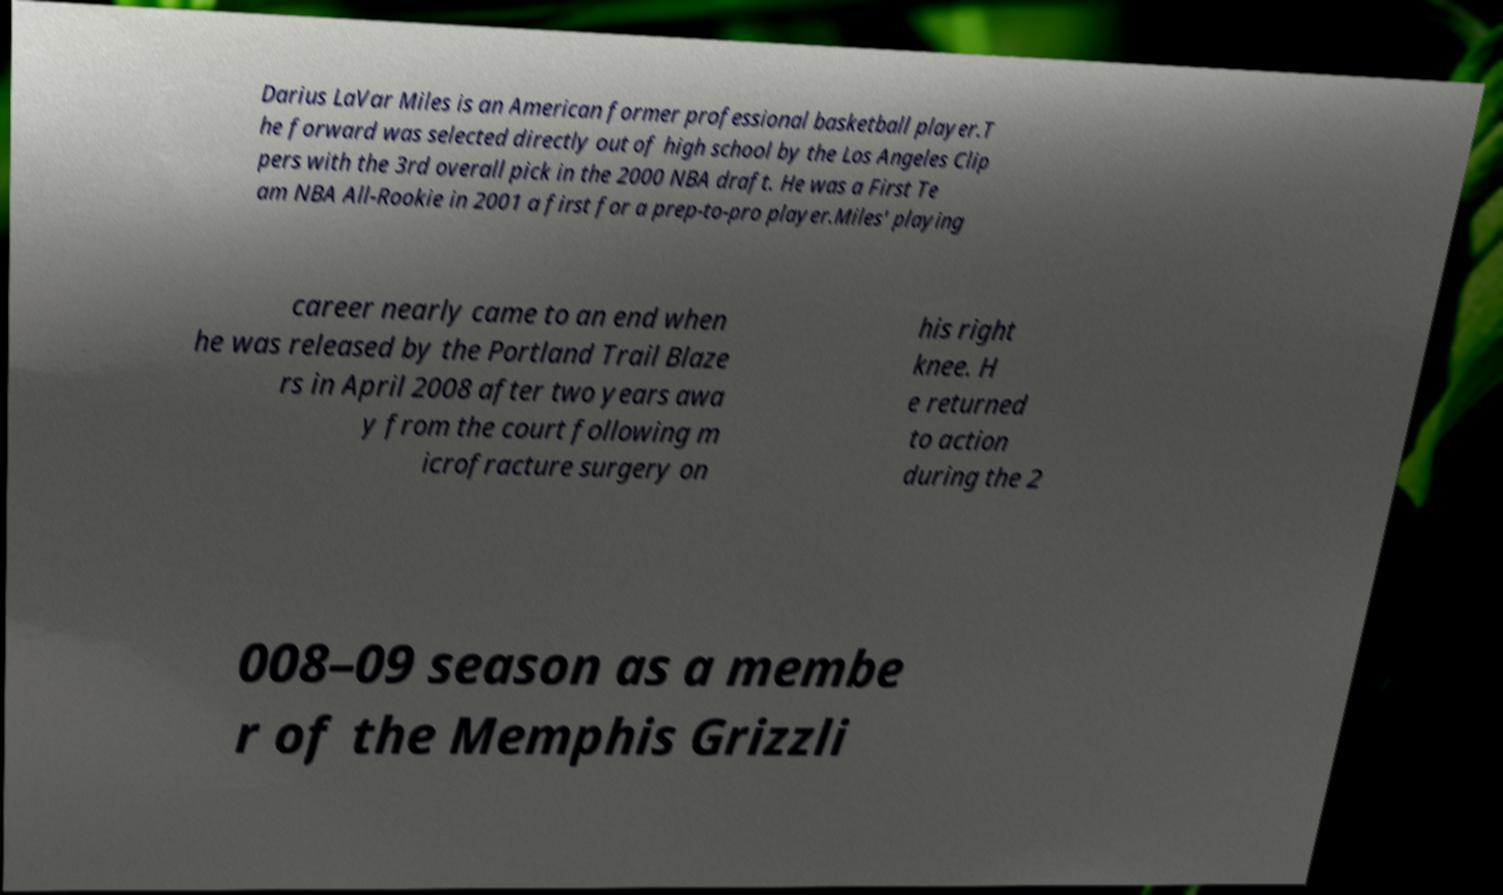Can you accurately transcribe the text from the provided image for me? Darius LaVar Miles is an American former professional basketball player.T he forward was selected directly out of high school by the Los Angeles Clip pers with the 3rd overall pick in the 2000 NBA draft. He was a First Te am NBA All-Rookie in 2001 a first for a prep-to-pro player.Miles' playing career nearly came to an end when he was released by the Portland Trail Blaze rs in April 2008 after two years awa y from the court following m icrofracture surgery on his right knee. H e returned to action during the 2 008–09 season as a membe r of the Memphis Grizzli 